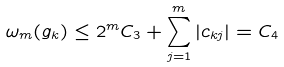Convert formula to latex. <formula><loc_0><loc_0><loc_500><loc_500>\omega _ { m } ( g _ { k } ) \leq 2 ^ { m } C _ { 3 } + \sum _ { j = 1 } ^ { m } | c _ { k j } | = C _ { 4 }</formula> 